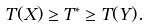Convert formula to latex. <formula><loc_0><loc_0><loc_500><loc_500>T ( X ) \geq T ^ { * } \geq T ( Y ) .</formula> 